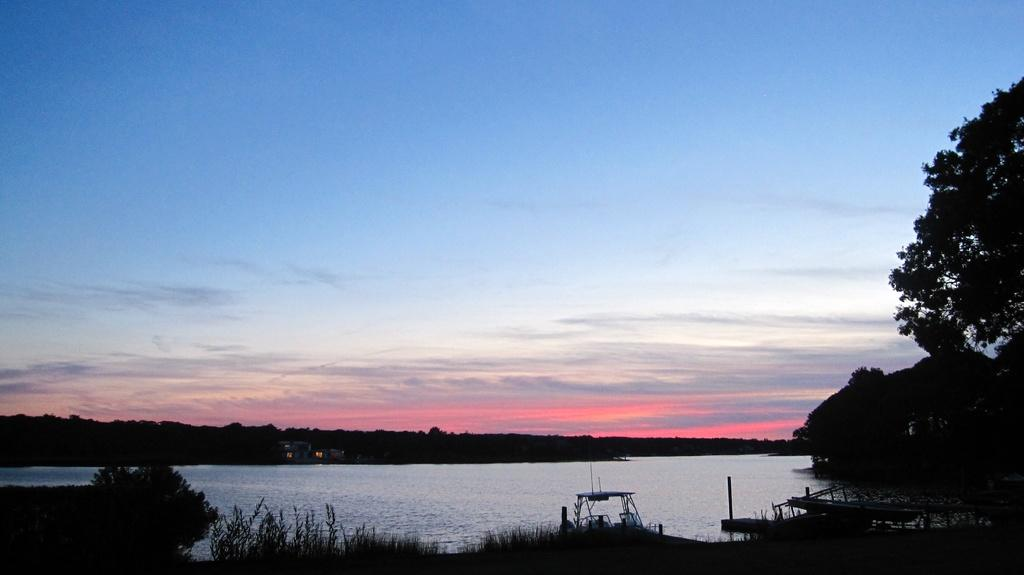What is the primary element visible in the image? There is water in the image. What other natural elements can be seen in the image? There are plants and trees in the image. What is visible in the background of the image? The sky is visible in the background of the image. What can be observed in the sky? Clouds are present in the sky. How many bears can be seen sitting on the seat in the image? There are no bears or seats present in the image. 